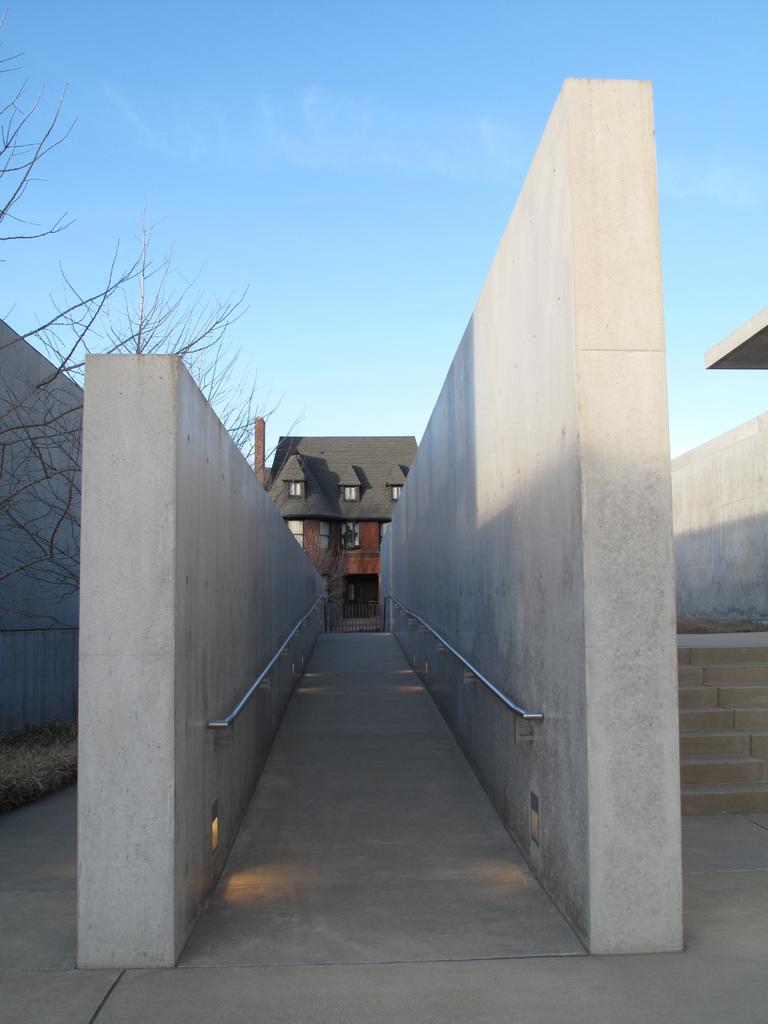What structures are located in the middle of the image? There are walls in the middle of the image. What type of vegetation is on the left side of the image? There is a tree on the left side of the image. What can be seen in the background of the image? There is a building in the background of the image. What is visible at the top of the image? The sky is visible at the top of the image. How many dinosaurs are visible in the image? There are no dinosaurs present in the image. What type of cloud is depicted in the sky? The provided facts do not mention any clouds in the sky, so we cannot determine the type of cloud. 